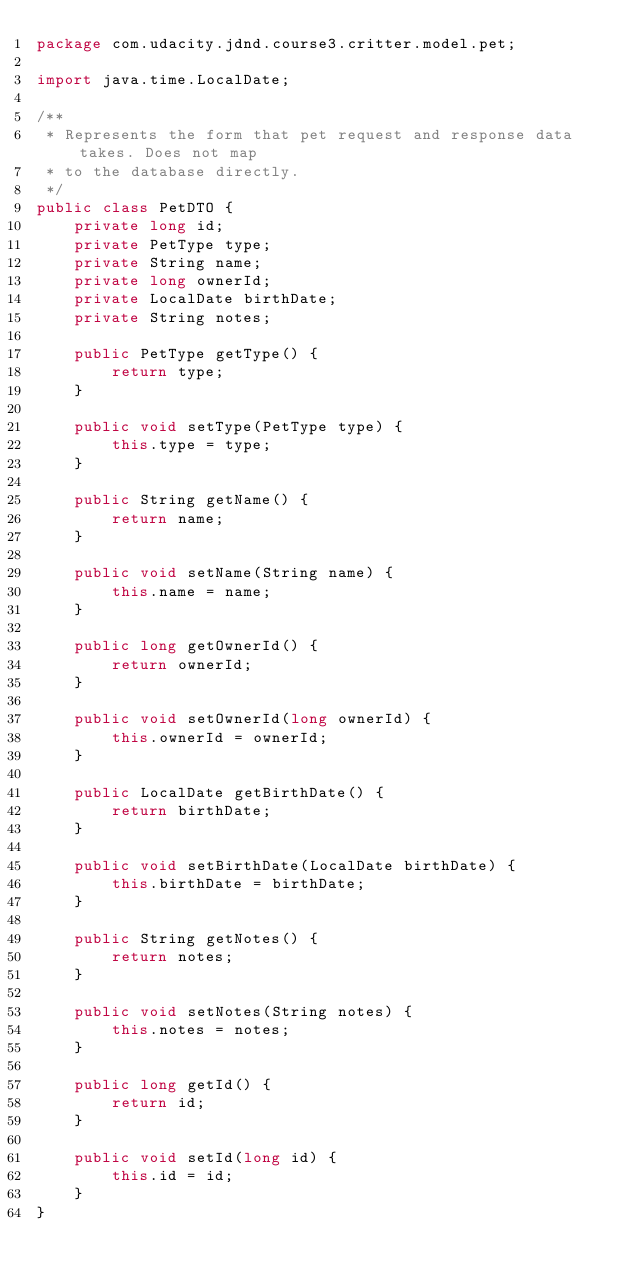<code> <loc_0><loc_0><loc_500><loc_500><_Java_>package com.udacity.jdnd.course3.critter.model.pet;

import java.time.LocalDate;

/**
 * Represents the form that pet request and response data takes. Does not map
 * to the database directly.
 */
public class PetDTO {
    private long id;
    private PetType type;
    private String name;
    private long ownerId;
    private LocalDate birthDate;
    private String notes;

    public PetType getType() {
        return type;
    }

    public void setType(PetType type) {
        this.type = type;
    }

    public String getName() {
        return name;
    }

    public void setName(String name) {
        this.name = name;
    }

    public long getOwnerId() {
        return ownerId;
    }

    public void setOwnerId(long ownerId) {
        this.ownerId = ownerId;
    }

    public LocalDate getBirthDate() {
        return birthDate;
    }

    public void setBirthDate(LocalDate birthDate) {
        this.birthDate = birthDate;
    }

    public String getNotes() {
        return notes;
    }

    public void setNotes(String notes) {
        this.notes = notes;
    }

    public long getId() {
        return id;
    }

    public void setId(long id) {
        this.id = id;
    }
}
</code> 